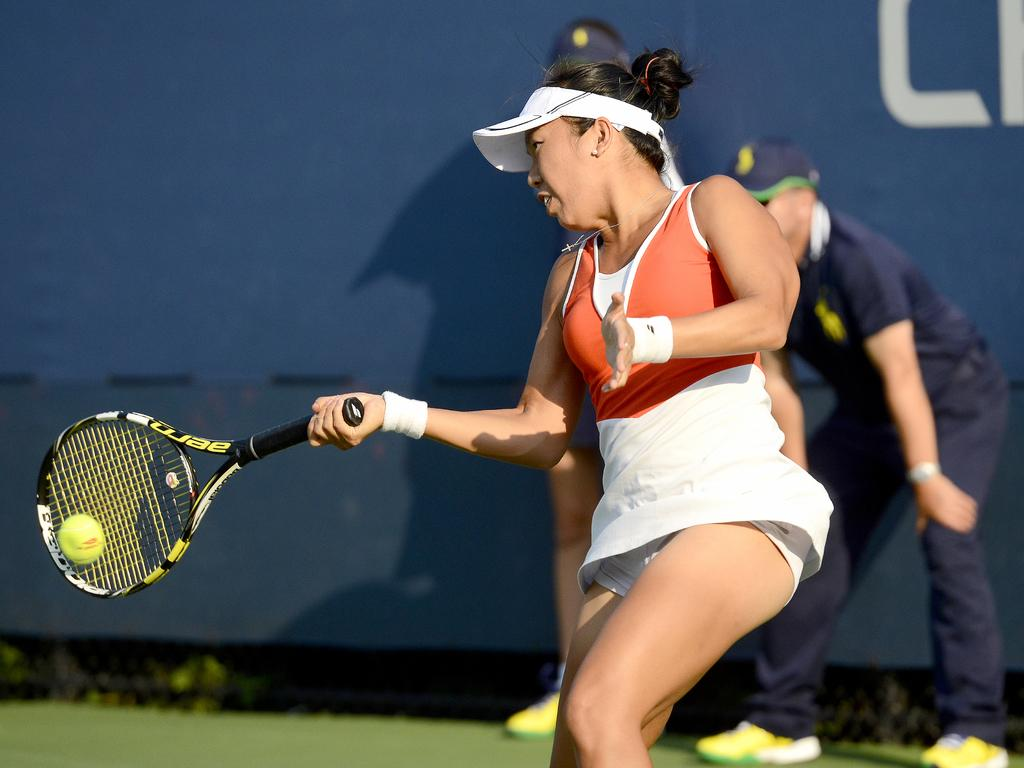What is happening in the image? There are people standing in a ground, and one person is playing tennis. What is the person playing tennis wearing? The person playing tennis is wearing a red jacket. Can you describe the location of the red jacket in the image? The red jacket is in the center of the image. What type of oatmeal is being served in the image? There is no oatmeal present in the image; it features people playing tennis. How many streetlights are visible in the town in the image? There is no town or streetlights visible in the image; it is focused on people playing tennis. 